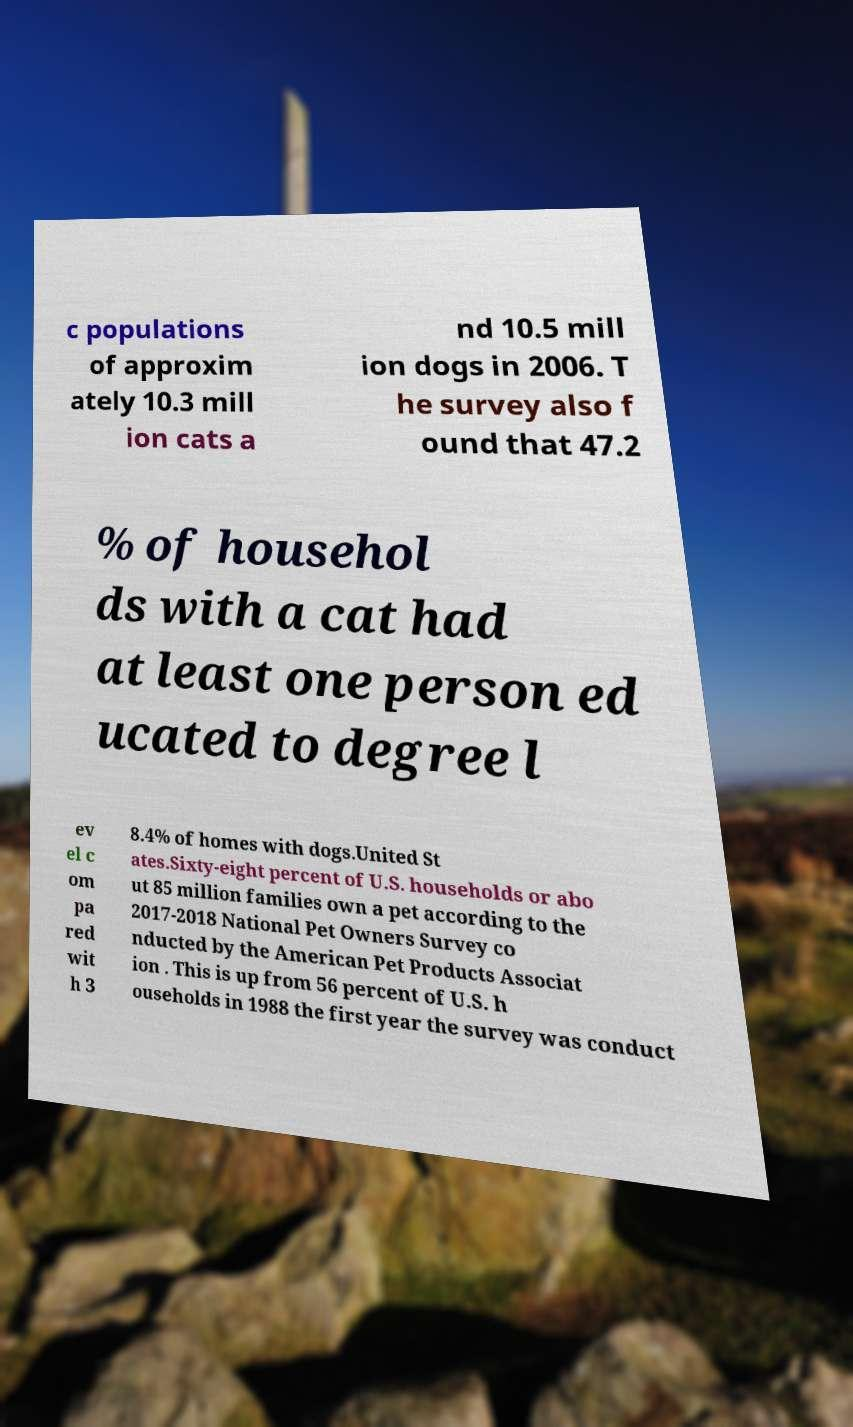There's text embedded in this image that I need extracted. Can you transcribe it verbatim? c populations of approxim ately 10.3 mill ion cats a nd 10.5 mill ion dogs in 2006. T he survey also f ound that 47.2 % of househol ds with a cat had at least one person ed ucated to degree l ev el c om pa red wit h 3 8.4% of homes with dogs.United St ates.Sixty-eight percent of U.S. households or abo ut 85 million families own a pet according to the 2017-2018 National Pet Owners Survey co nducted by the American Pet Products Associat ion . This is up from 56 percent of U.S. h ouseholds in 1988 the first year the survey was conduct 